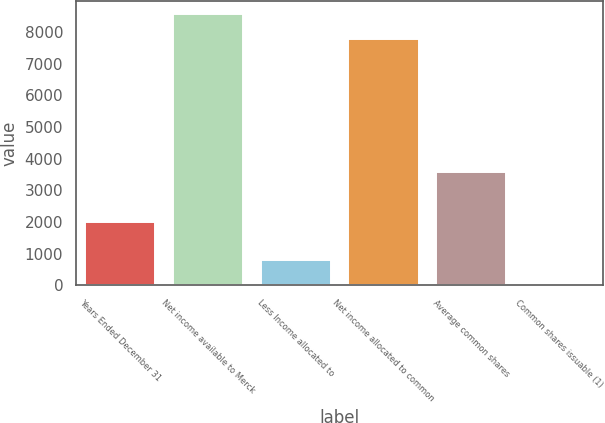<chart> <loc_0><loc_0><loc_500><loc_500><bar_chart><fcel>Years Ended December 31<fcel>Net income available to Merck<fcel>Less Income allocated to<fcel>Net income allocated to common<fcel>Average common shares<fcel>Common shares issuable (1)<nl><fcel>2008<fcel>8567.77<fcel>786.87<fcel>7787.6<fcel>3568.34<fcel>6.7<nl></chart> 